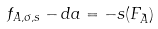Convert formula to latex. <formula><loc_0><loc_0><loc_500><loc_500>f _ { A , \sigma , s } - d a = - s ( F _ { \tilde { A } } )</formula> 